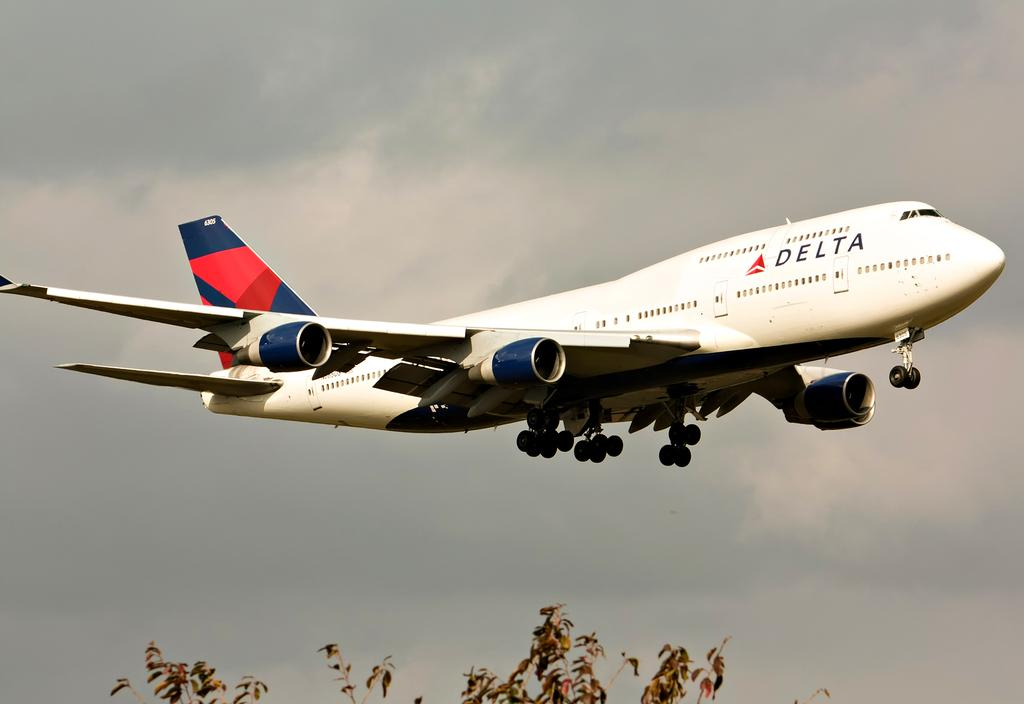<image>
Share a concise interpretation of the image provided. delta airliner with wheels down getting ready to land 